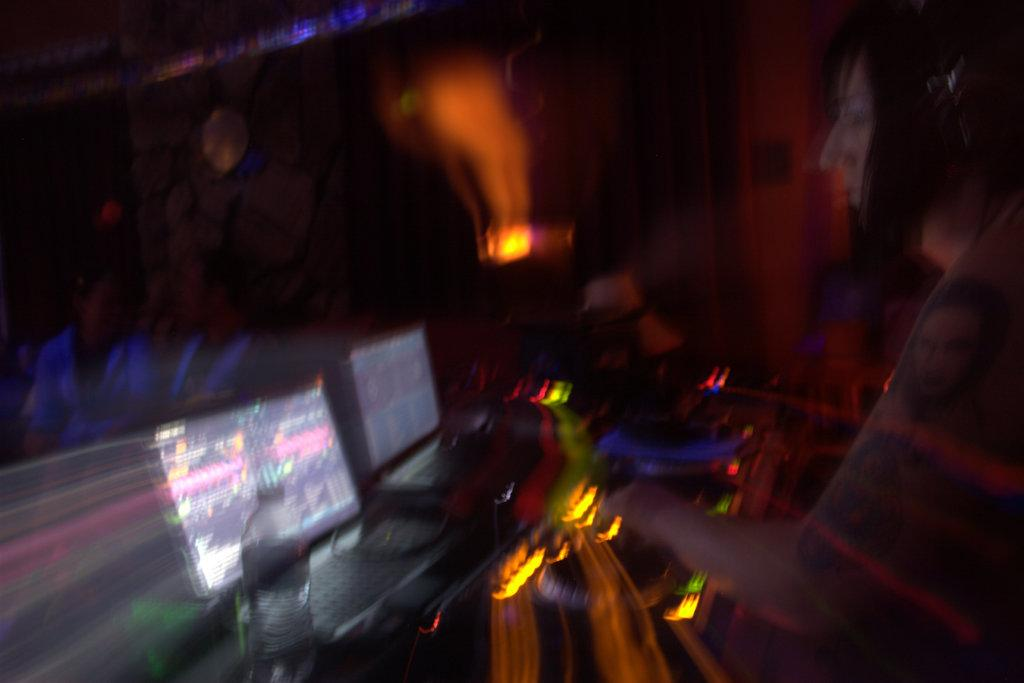Who or what is present in the image? There are people in the image. What objects can be seen on the table in the image? There are laptops, a bottle, and other devices on the table in the image. What type of cable is being used by the people in the image? There is no cable visible in the image; the people are using laptops and other devices. 